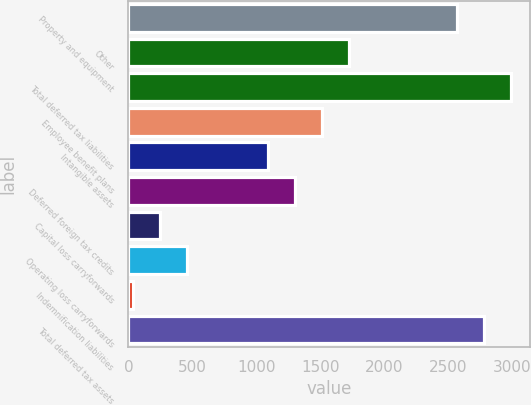<chart> <loc_0><loc_0><loc_500><loc_500><bar_chart><fcel>Property and equipment<fcel>Other<fcel>Total deferred tax liabilities<fcel>Employee benefit plans<fcel>Intangible assets<fcel>Deferred foreign tax credits<fcel>Capital loss carryforwards<fcel>Operating loss carryforwards<fcel>Indemnification liabilities<fcel>Total deferred tax assets<nl><fcel>2566.7<fcel>1723.3<fcel>2988.4<fcel>1512.45<fcel>1090.75<fcel>1301.6<fcel>247.35<fcel>458.2<fcel>36.5<fcel>2777.55<nl></chart> 